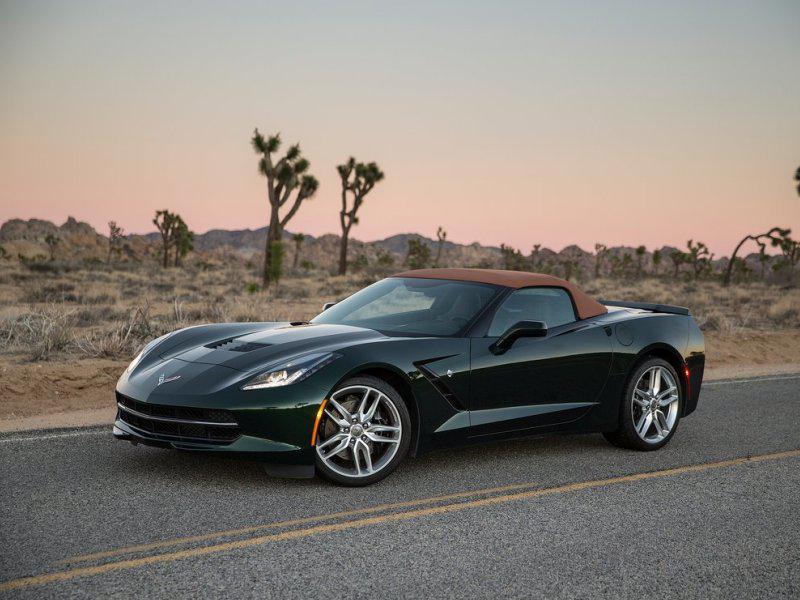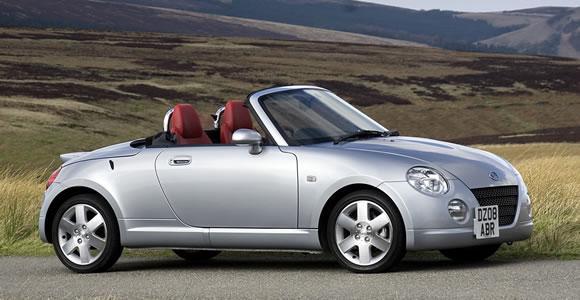The first image is the image on the left, the second image is the image on the right. Analyze the images presented: Is the assertion "Each image shows a car with its top down, and one image shows someone behind the wheel of a car." valid? Answer yes or no. No. The first image is the image on the left, the second image is the image on the right. For the images shown, is this caption "Both convertibles have their tops down." true? Answer yes or no. No. 